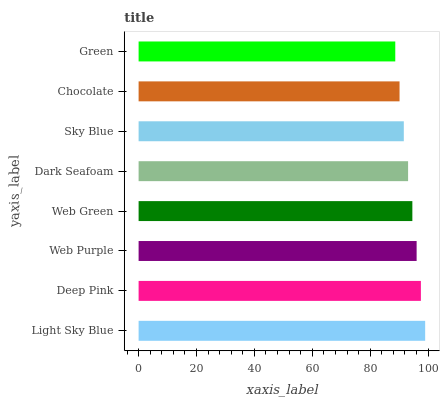Is Green the minimum?
Answer yes or no. Yes. Is Light Sky Blue the maximum?
Answer yes or no. Yes. Is Deep Pink the minimum?
Answer yes or no. No. Is Deep Pink the maximum?
Answer yes or no. No. Is Light Sky Blue greater than Deep Pink?
Answer yes or no. Yes. Is Deep Pink less than Light Sky Blue?
Answer yes or no. Yes. Is Deep Pink greater than Light Sky Blue?
Answer yes or no. No. Is Light Sky Blue less than Deep Pink?
Answer yes or no. No. Is Web Green the high median?
Answer yes or no. Yes. Is Dark Seafoam the low median?
Answer yes or no. Yes. Is Chocolate the high median?
Answer yes or no. No. Is Green the low median?
Answer yes or no. No. 